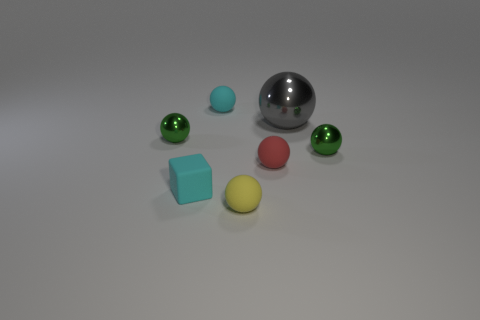Subtract 2 balls. How many balls are left? 4 Subtract all green spheres. How many spheres are left? 4 Subtract all tiny green balls. How many balls are left? 4 Subtract all green spheres. Subtract all yellow cubes. How many spheres are left? 4 Add 3 small blue cylinders. How many objects exist? 10 Subtract all balls. How many objects are left? 1 Add 5 yellow rubber blocks. How many yellow rubber blocks exist? 5 Subtract 0 brown spheres. How many objects are left? 7 Subtract all gray things. Subtract all cyan rubber balls. How many objects are left? 5 Add 6 tiny yellow balls. How many tiny yellow balls are left? 7 